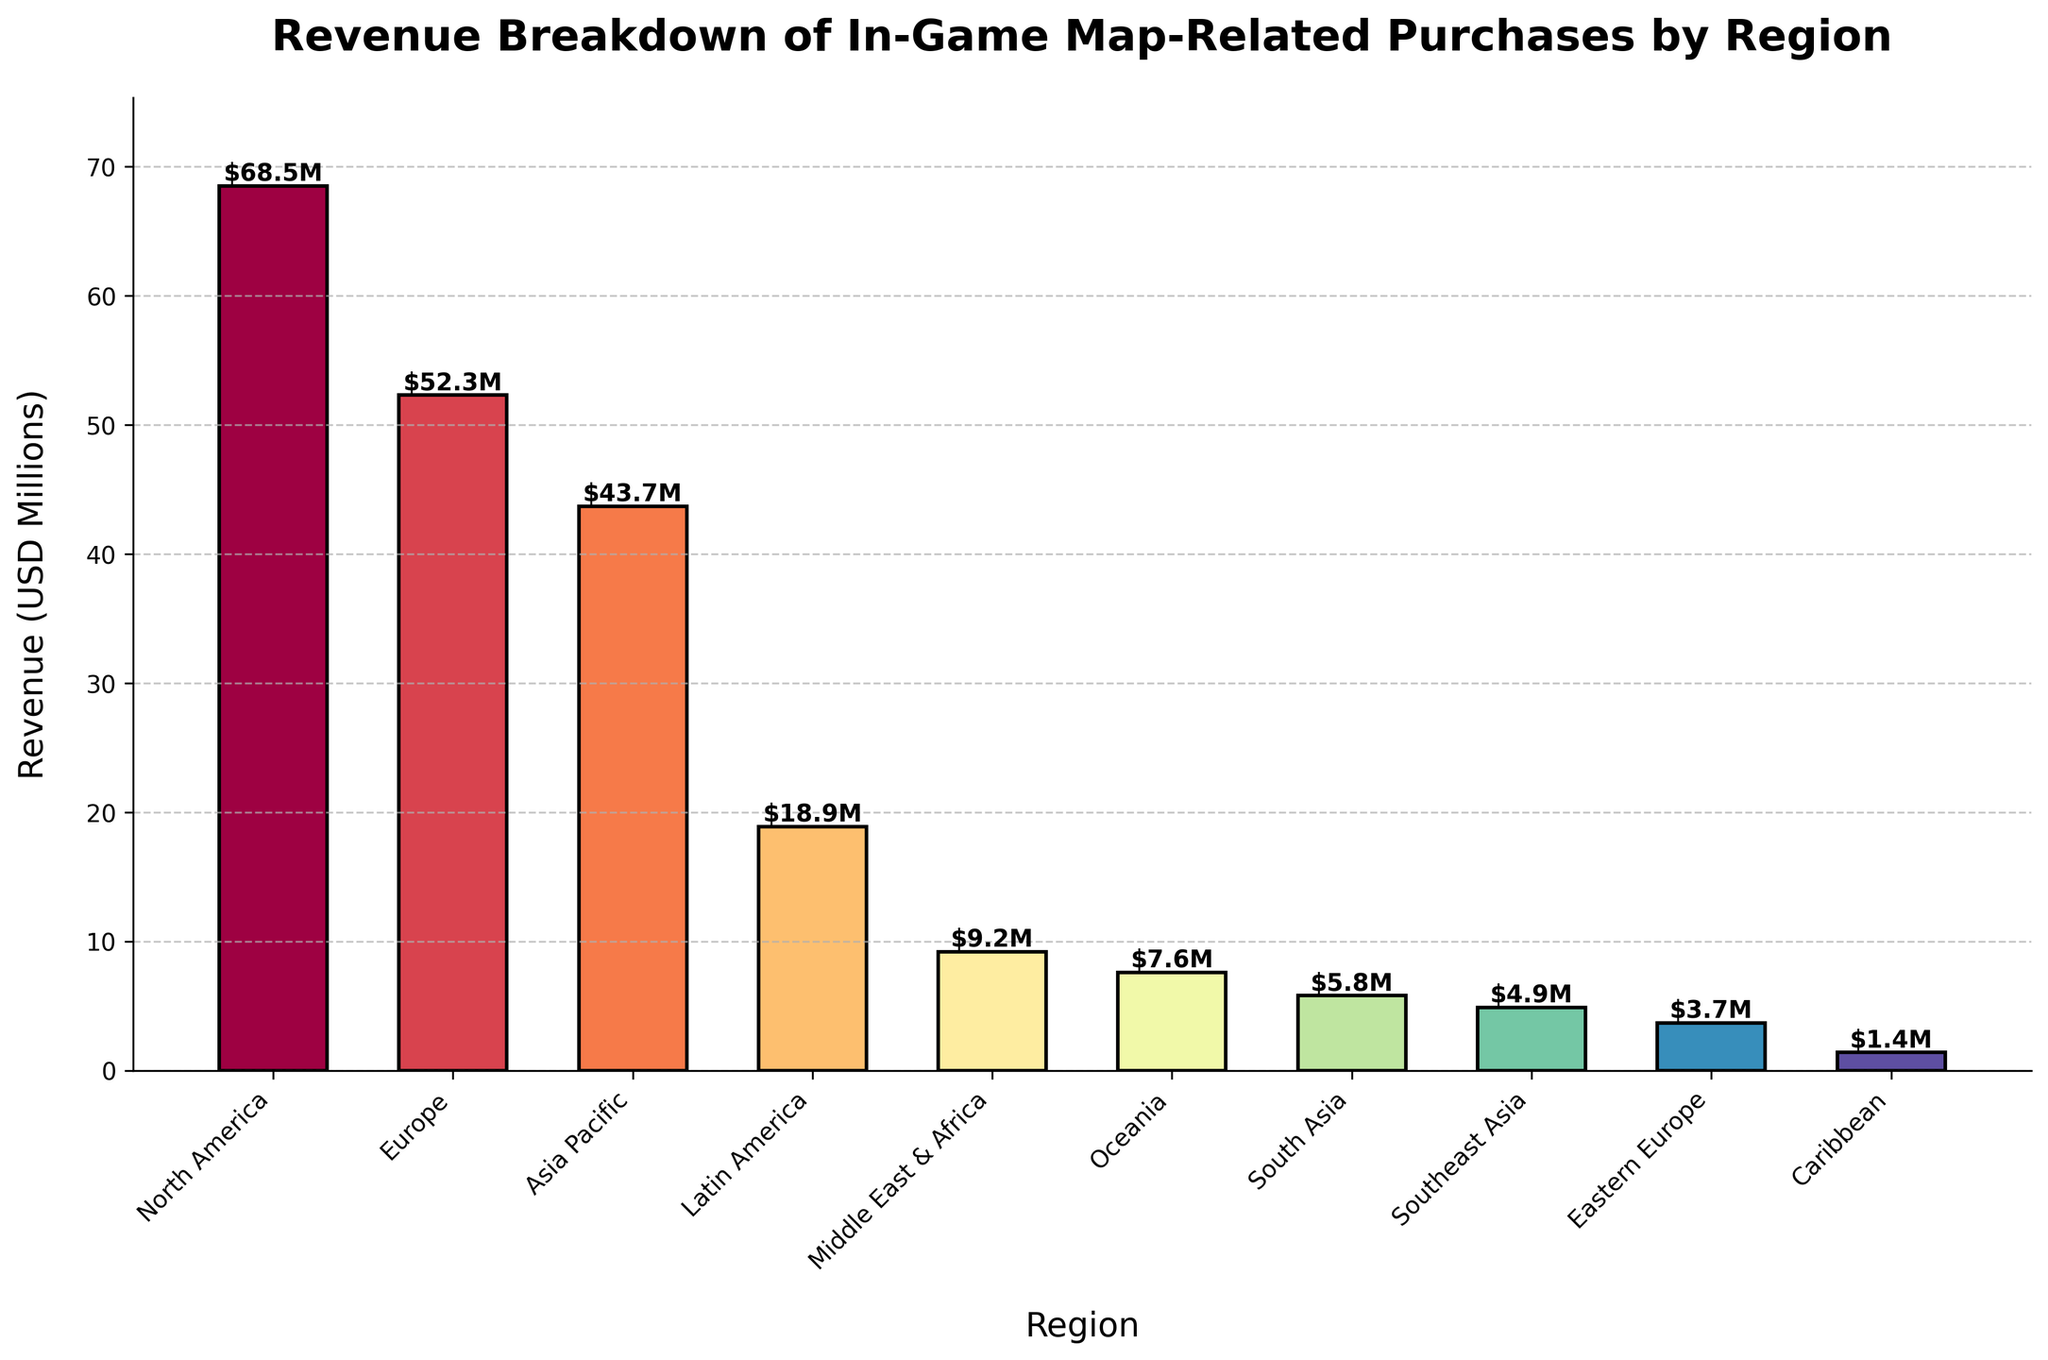Which region has the highest revenue from in-game map-related purchases? The bar representing North America is the tallest in the chart, indicating it has the highest revenue.
Answer: North America How much more revenue does North America generate compared to Europe? The revenue for North America is $68.5M, and for Europe, it is $52.3M. Subtracting Europe's revenue from North America's revenue gives $68.5M - $52.3M = $16.2M.
Answer: $16.2M What is the combined revenue of Latin America, Middle East & Africa, and Oceania? Add the revenues of Latin America ($18.9M), Middle East & Africa ($9.2M), and Oceania ($7.6M). The sum is $18.9M + $9.2M + $7.6M = $35.7M.
Answer: $35.7M Which regions have a revenue less than $10 million? By inspecting the bars, Middle East & Africa ($9.2M), Oceania ($7.6M), South Asia ($5.8M), Southeast Asia ($4.9M), Eastern Europe ($3.7M), and Caribbean ($1.4M) all have revenues less than $10M.
Answer: Middle East & Africa, Oceania, South Asia, Southeast Asia, Eastern Europe, Caribbean What is the average revenue of the top three revenue-generating regions? Top three regions by revenue are North America ($68.5M), Europe ($52.3M), and Asia Pacific ($43.7M). The average is calculated as ($68.5M + $52.3M + $43.7M) / 3 = $164.5M / 3 ≈ $54.83M.
Answer: $54.83M Which region has the smallest revenue and what is its value? The shortest bar in the chart represents the Caribbean with the smallest revenue value of $1.4M.
Answer: Caribbean, $1.4M How many regions have a revenue greater than $40 million? North America ($68.5M), Europe ($52.3M), and Asia Pacific ($43.7M) each have a revenue greater than $40 million, totaling three regions.
Answer: 3 By how much does the revenue of Asia Pacific exceed that of South Asia? The revenue for Asia Pacific is $43.7M, and for South Asia, it is $5.8M. Subtract South Asia's revenue from Asia Pacific's revenue: $43.7M - $5.8M = $37.9M.
Answer: $37.9M What is the total revenue generated by all the regions combined? Sum the revenues of all the regions: $68.5M + $52.3M + $43.7M + $18.9M + $9.2M + $7.6M + $5.8M + $4.9M + $3.7M + $1.4M = $216M.
Answer: $216M Which regions have revenues depicted in the warmest color tones? Warm color tones like reds and oranges typically appear in North America, Europe, and Asia Pacific, which are the top three revenue-generating regions.
Answer: North America, Europe, Asia Pacific 